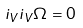<formula> <loc_0><loc_0><loc_500><loc_500>i _ { V } i _ { V } \Omega = 0</formula> 